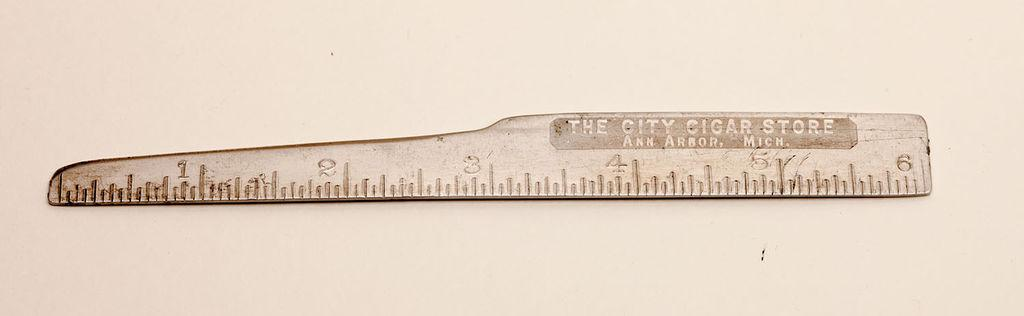<image>
Summarize the visual content of the image. A ruler that says the City Cigar Store on it 